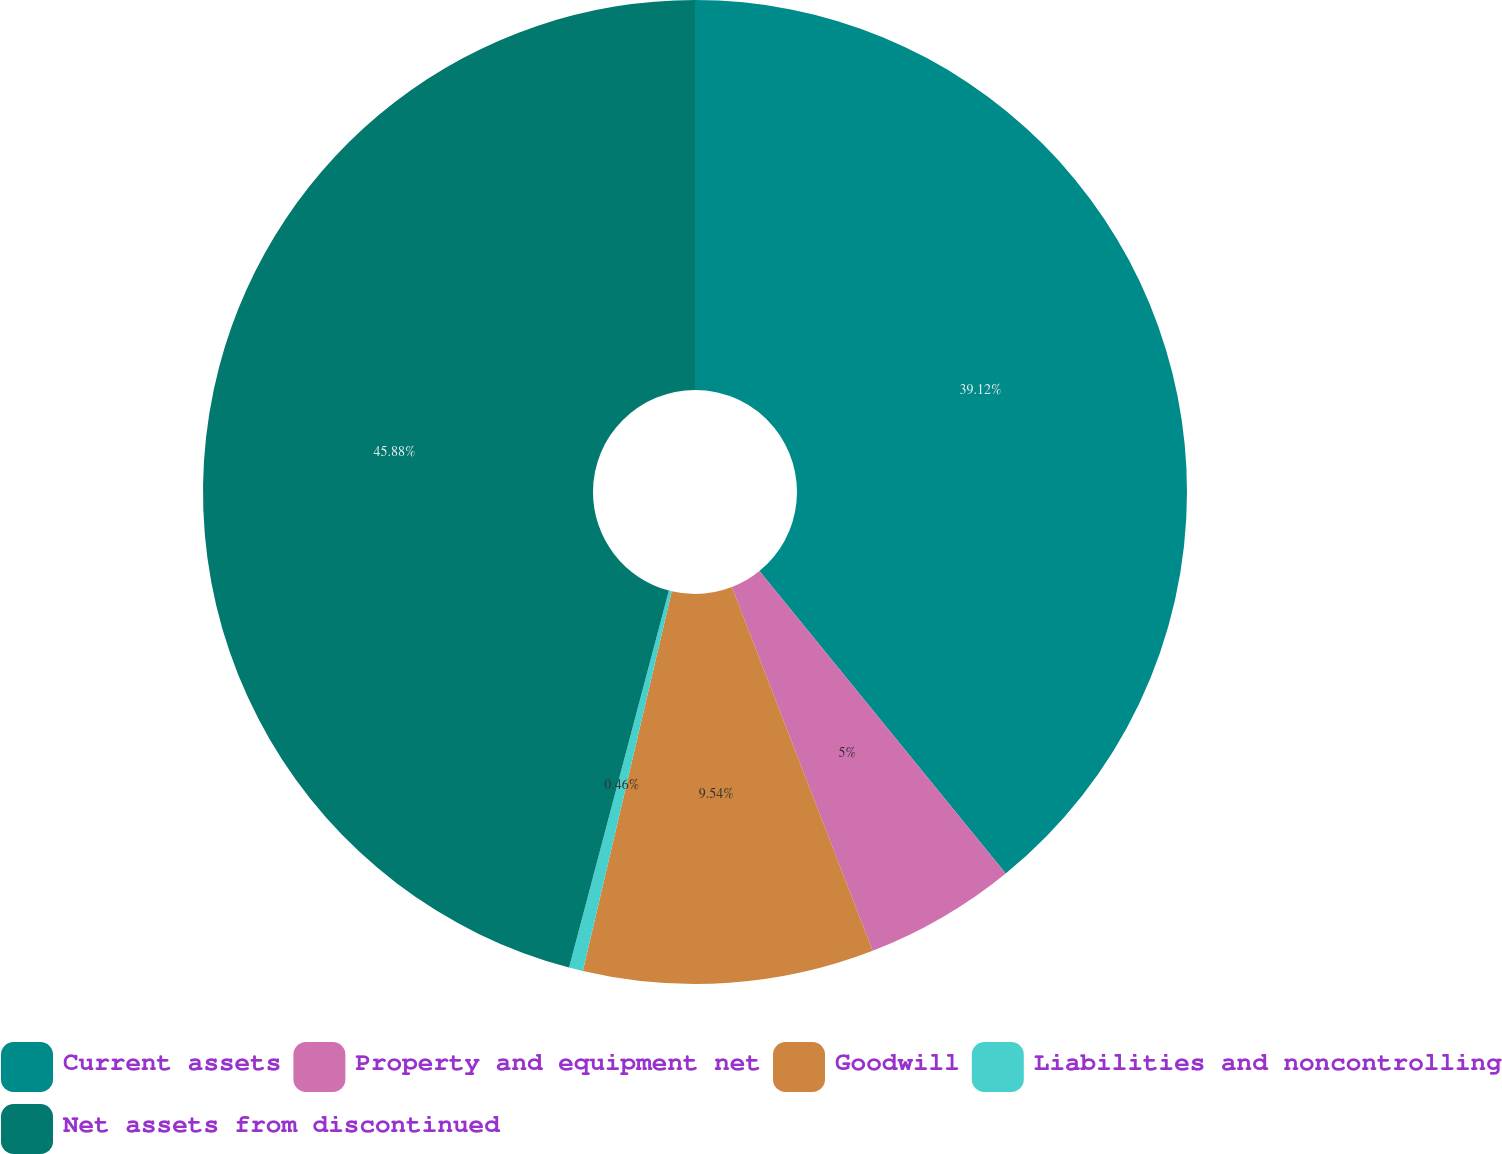<chart> <loc_0><loc_0><loc_500><loc_500><pie_chart><fcel>Current assets<fcel>Property and equipment net<fcel>Goodwill<fcel>Liabilities and noncontrolling<fcel>Net assets from discontinued<nl><fcel>39.12%<fcel>5.0%<fcel>9.54%<fcel>0.46%<fcel>45.88%<nl></chart> 